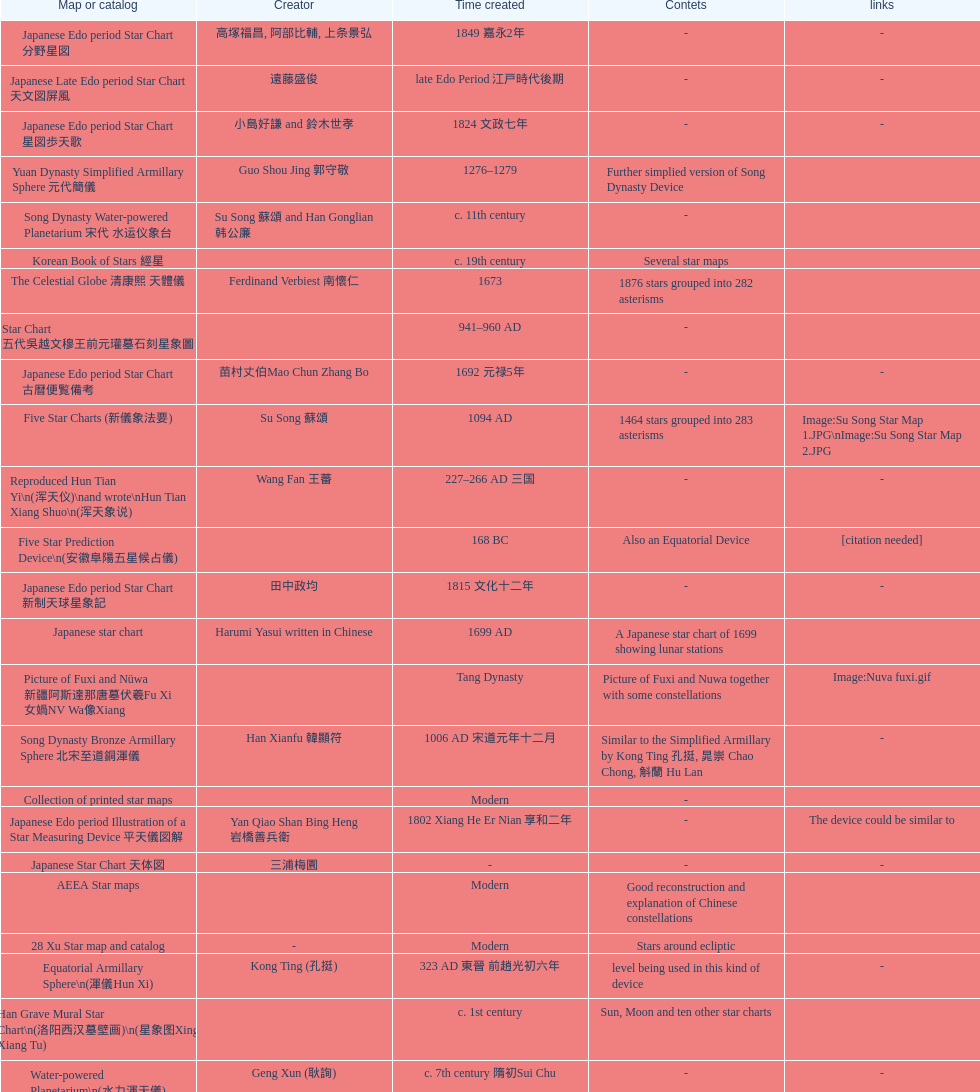When was the first map or catalog created? C. 4000 b.c. 